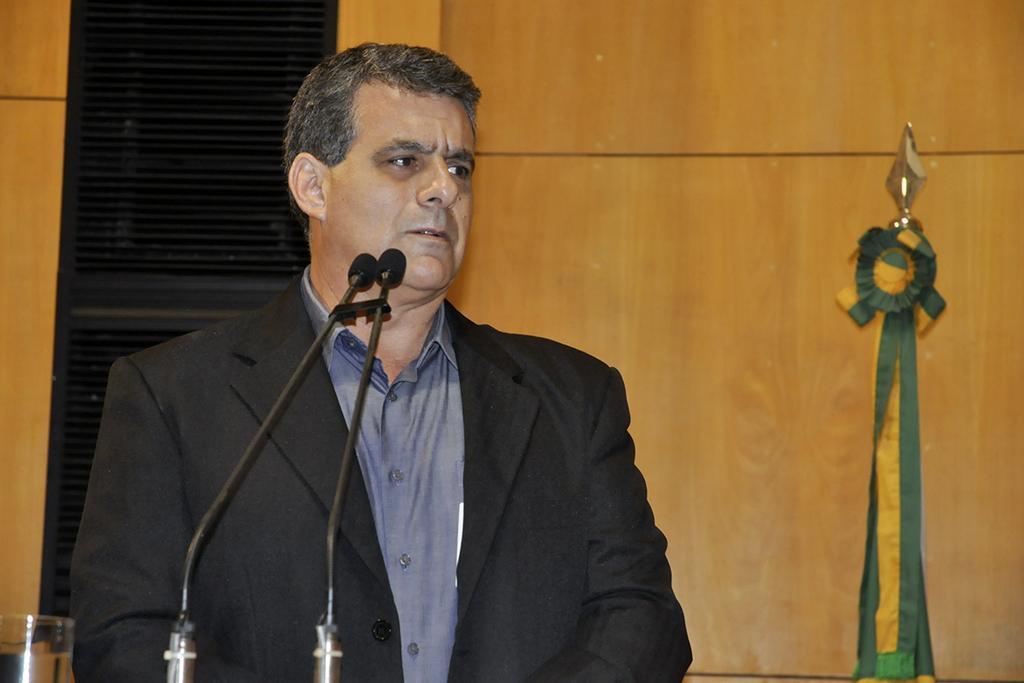Describe this image in one or two sentences. In the image we can see a man wearing a blazer and shirt. These are the microphones, glass and wooden wall. 